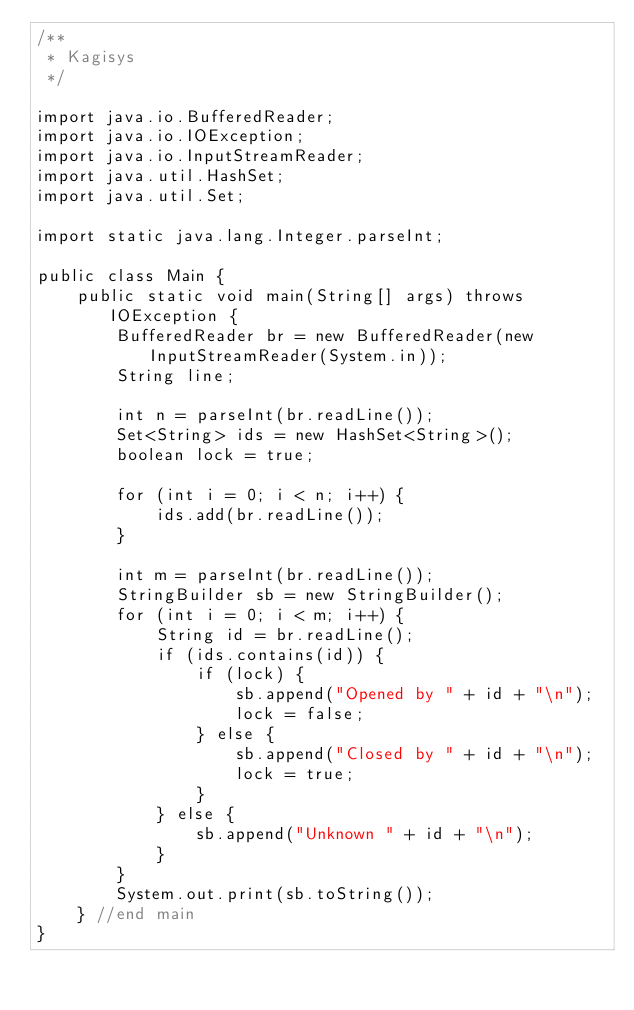<code> <loc_0><loc_0><loc_500><loc_500><_Java_>/**
 * Kagisys
 */

import java.io.BufferedReader;
import java.io.IOException;
import java.io.InputStreamReader;
import java.util.HashSet;
import java.util.Set;

import static java.lang.Integer.parseInt;

public class Main {
	public static void main(String[] args) throws IOException {
		BufferedReader br = new BufferedReader(new InputStreamReader(System.in));
		String line;

		int n = parseInt(br.readLine());
		Set<String> ids = new HashSet<String>();
		boolean lock = true;

		for (int i = 0; i < n; i++) {
			ids.add(br.readLine());
		}

		int m = parseInt(br.readLine());
		StringBuilder sb = new StringBuilder();
		for (int i = 0; i < m; i++) {
			String id = br.readLine();
			if (ids.contains(id)) {
				if (lock) {
					sb.append("Opened by " + id + "\n");
					lock = false;
				} else {
					sb.append("Closed by " + id + "\n");
					lock = true;
				}
			} else {
				sb.append("Unknown " + id + "\n");
			}
		}
		System.out.print(sb.toString());
	} //end main
}</code> 